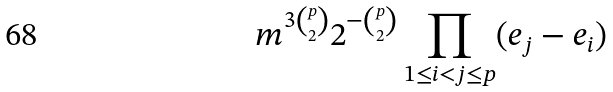<formula> <loc_0><loc_0><loc_500><loc_500>m ^ { 3 \binom { p } { 2 } } 2 ^ { - \binom { p } { 2 } } \prod _ { 1 \leq i < j \leq p } ( e _ { j } - e _ { i } )</formula> 